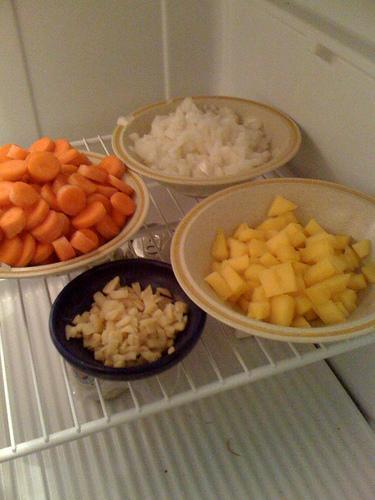How many of the bowls are black?
Give a very brief answer. 1. 